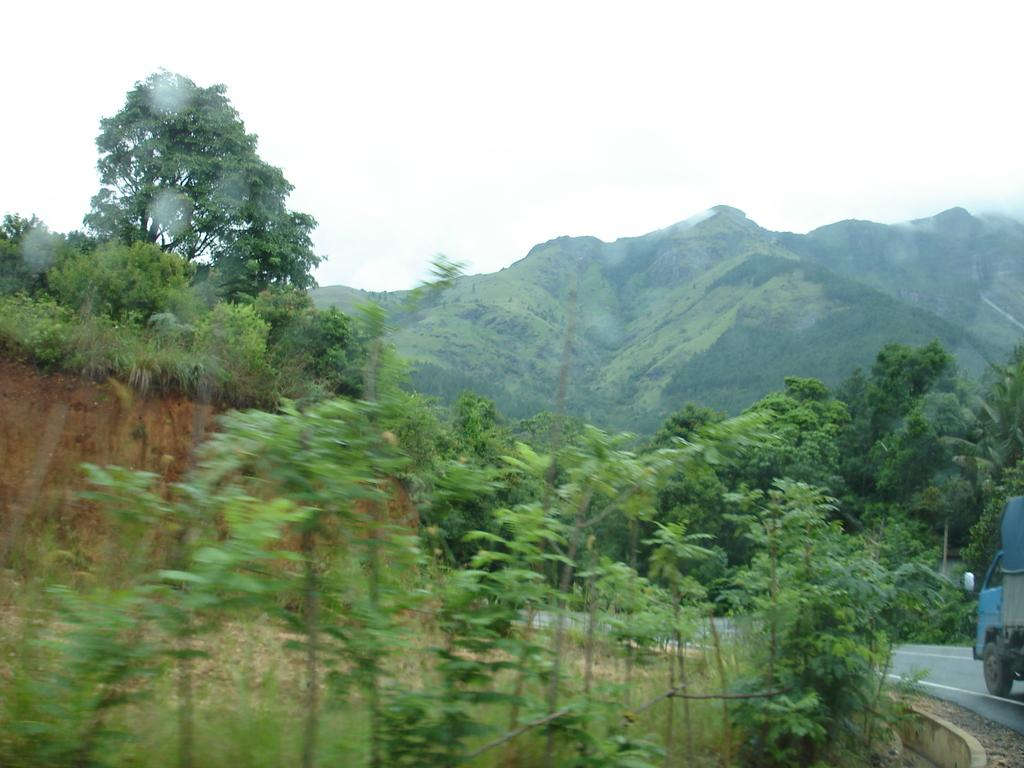What can be seen in the foreground of the image? There are trees in the foreground of the image. What is happening on the right side of the image? A vehicle is moving on the road on the right side of the image. What can be seen in the background of the image? There are trees and mountains in the background of the image. What is visible above the mountains in the image? The sky is visible in the background of the image. Can you see any feathers floating in the air in the image? There are no feathers visible in the image. What type of vegetable is growing on the mountains in the image? There are no vegetables present in the image; the background features trees and mountains. 